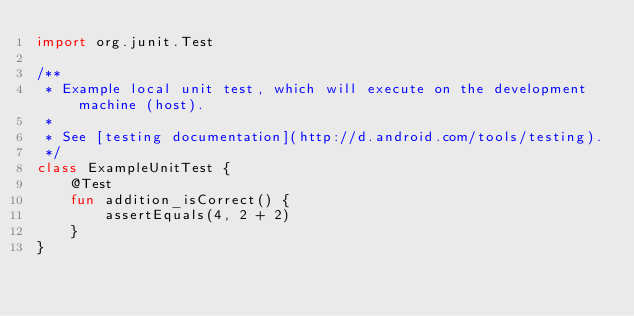Convert code to text. <code><loc_0><loc_0><loc_500><loc_500><_Kotlin_>import org.junit.Test

/**
 * Example local unit test, which will execute on the development machine (host).
 *
 * See [testing documentation](http://d.android.com/tools/testing).
 */
class ExampleUnitTest {
    @Test
    fun addition_isCorrect() {
        assertEquals(4, 2 + 2)
    }
}
</code> 